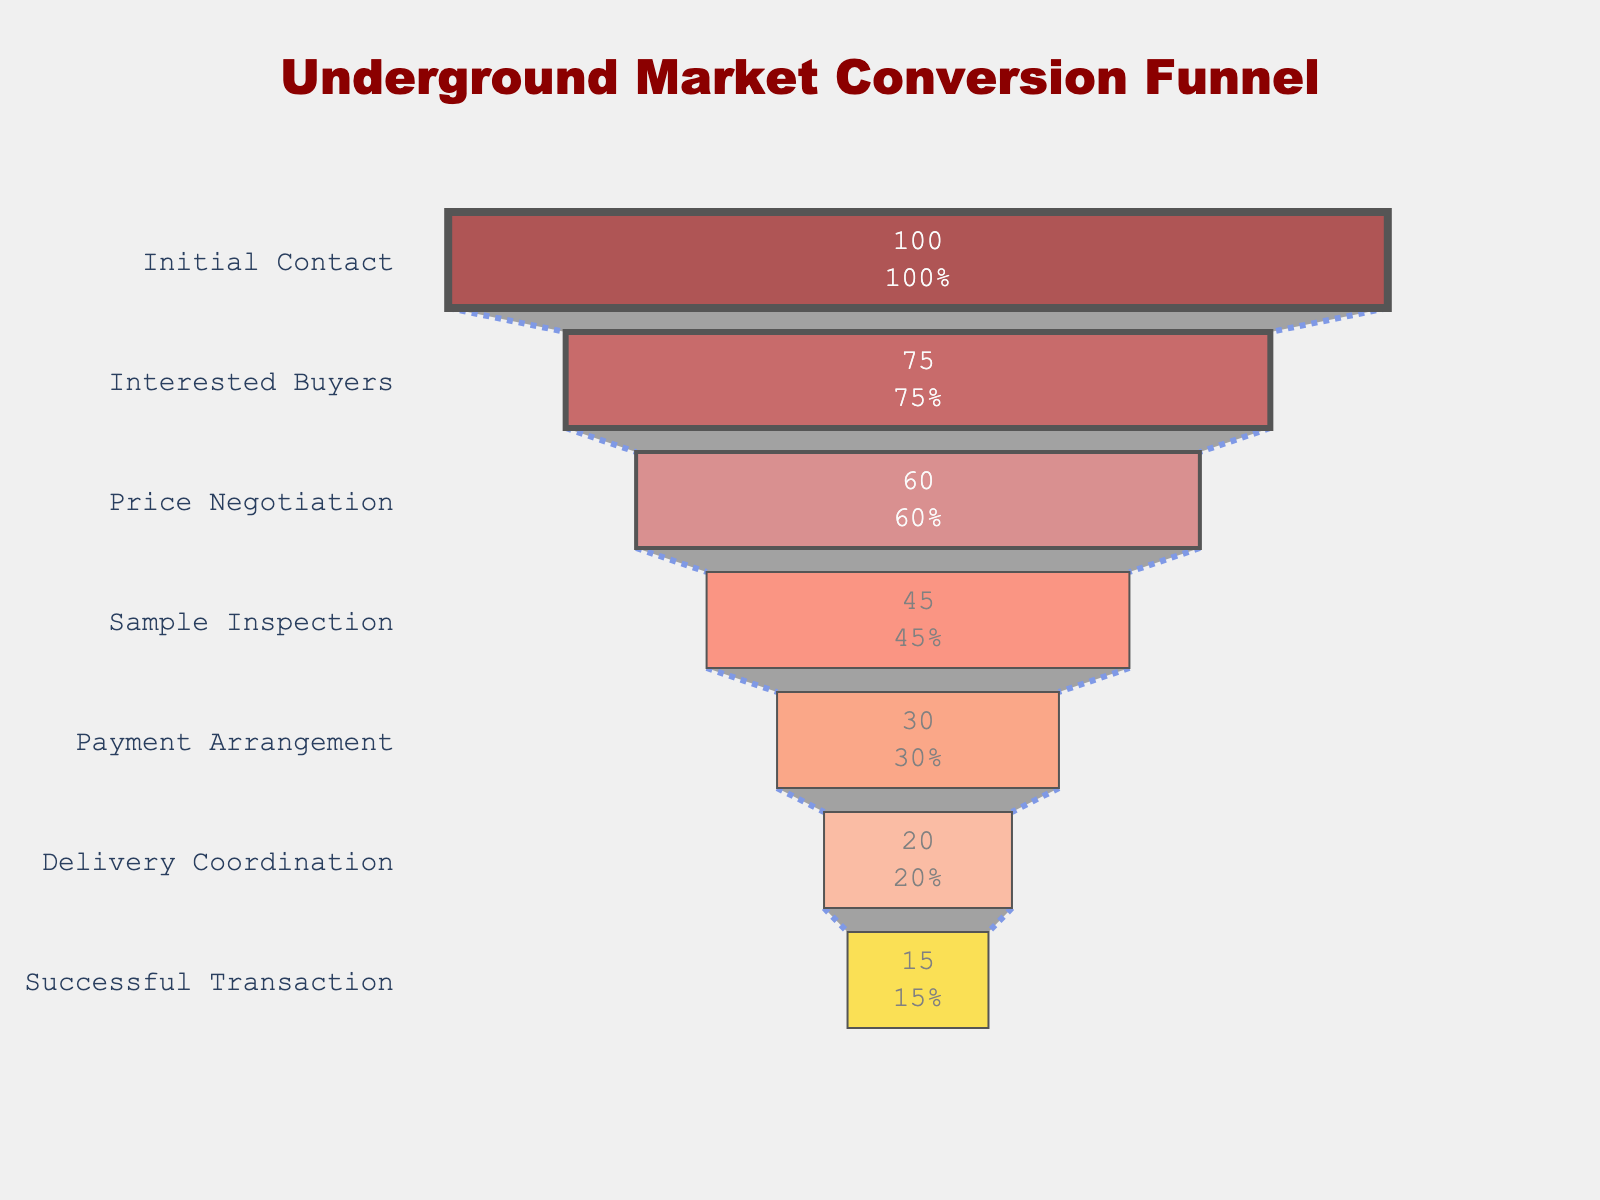what is the title of the figure? The title is displayed at the top of the funnel chart, indicating the overall subject of the visualization. The title reads "Underground Market Conversion Funnel".
Answer: Underground Market Conversion Funnel What is the conversion rate at the 'Interested Buyers' stage? To find the conversion rate at the 'Interested Buyers' stage, refer to the corresponding section of the funnel chart, which indicates 75%.
Answer: 75% At which stage do we see the highest drop in conversion rate? By observing the differences between conversion rates in adjacent stages, the largest drop is seen between 'Initial Contact' (100%) and 'Interested Buyers' (75%), a difference of 25%.
Answer: Initial Contact to Interested Buyers What is the drop in conversion rate from 'Sample Inspection' to 'Payment Arrangement'? Locate the conversion rates for both stages: 'Sample Inspection' (45%) and 'Payment Arrangement' (30%). The drop is 45% - 30% = 15%.
Answer: 15% Which stage has the most significant conversion retention from its previous stage? Calculate the differences between each adjacent stage: the smallest difference indicates the most significant retention. Between 'Payment Arrangement' (30%) and 'Delivery Coordination' (20%), the difference is only 10%, the smallest drop.
Answer: Payment Arrangement to Delivery Coordination How many stages are there in total? Count the distinct stages listed on the funnel chart: Initial Contact, Interested Buyers, Price Negotiation, Sample Inspection, Payment Arrangement, Delivery Coordination, Successful Transaction.
Answer: 7 Which stage has the lowest conversion rate? Look at the conversion rates listed for all stages and identify the smallest value. The 'Successful Transaction' stage has the lowest rate at 15%.
Answer: Successful Transaction What is the cumulative drop in conversion rate from the 'Initial Contact' to the 'Successful Transaction' stage? Calculate the difference between the highest (100% at Initial Contact) and lowest (15% at Successful Transaction) conversion rates. The drop is 100% - 15% = 85%.
Answer: 85% How does the conversion rate at 'Price Negotiation' compare to 'Delivery Coordination'? Compare the conversion rates at 'Price Negotiation' (60%) and 'Delivery Coordination' (20%). The rate at 'Price Negotiation' is higher by 40%.
Answer: 40% higher What percentage of those at the 'Interested Buyers' stage advance to a 'Successful Transaction'? Calculate the percentage of those at 'Interested Buyers' (75%) who reach 'Successful Transaction' (15%) by the ratio: (15% / 75%) * 100 = 20%.
Answer: 20% 